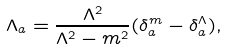Convert formula to latex. <formula><loc_0><loc_0><loc_500><loc_500>\Lambda _ { a } = \frac { \Lambda ^ { 2 } } { \Lambda ^ { 2 } - m ^ { 2 } } ( \delta _ { a } ^ { m } - \delta _ { a } ^ { \Lambda } ) ,</formula> 